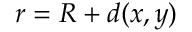Convert formula to latex. <formula><loc_0><loc_0><loc_500><loc_500>r = R + d ( x , y )</formula> 